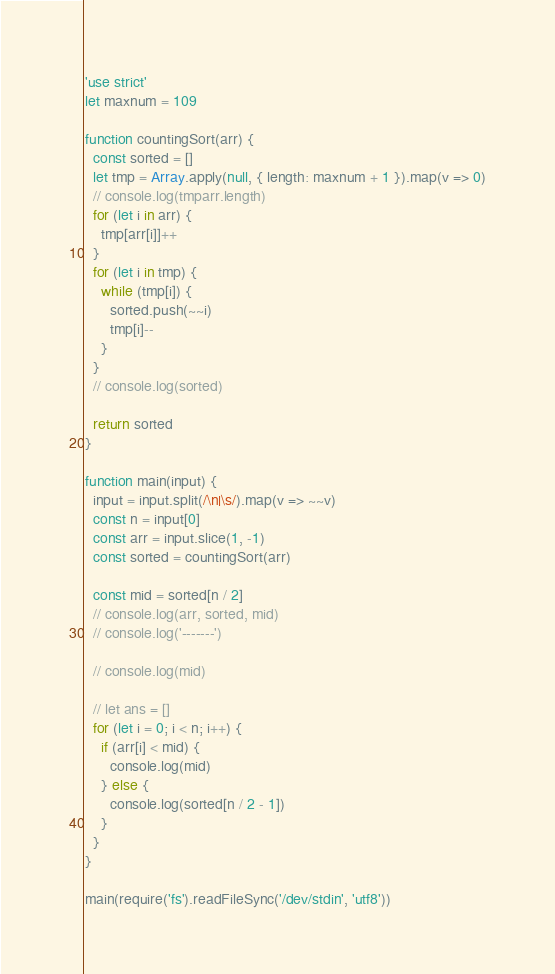Convert code to text. <code><loc_0><loc_0><loc_500><loc_500><_JavaScript_>
'use strict'
let maxnum = 109

function countingSort(arr) {
  const sorted = []
  let tmp = Array.apply(null, { length: maxnum + 1 }).map(v => 0)
  // console.log(tmparr.length)
  for (let i in arr) {
    tmp[arr[i]]++
  }
  for (let i in tmp) {
    while (tmp[i]) {
      sorted.push(~~i)
      tmp[i]--
    }
  }
  // console.log(sorted)

  return sorted
}

function main(input) {
  input = input.split(/\n|\s/).map(v => ~~v)
  const n = input[0]
  const arr = input.slice(1, -1)
  const sorted = countingSort(arr)

  const mid = sorted[n / 2]
  // console.log(arr, sorted, mid)
  // console.log('-------')

  // console.log(mid)

  // let ans = []
  for (let i = 0; i < n; i++) {
    if (arr[i] < mid) {
      console.log(mid)
    } else {
      console.log(sorted[n / 2 - 1])
    }
  }
}

main(require('fs').readFileSync('/dev/stdin', 'utf8'))
</code> 